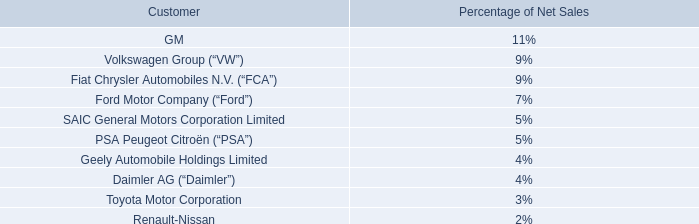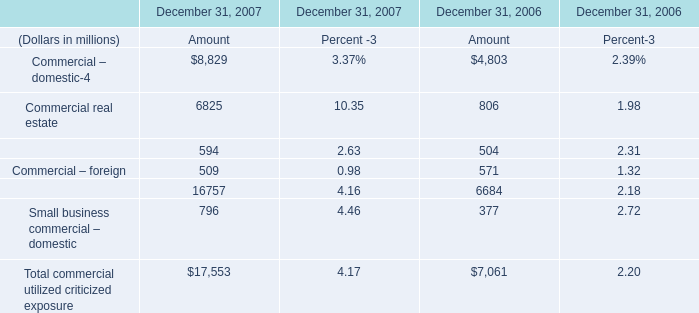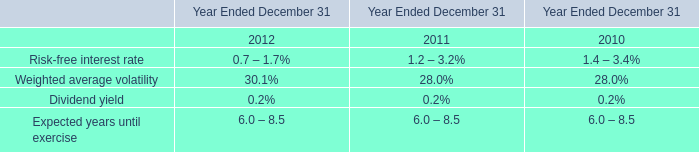Which Commercial lease financing continue to rise between 2007 and 2006? (in millions) 
Computations: (594 - 504)
Answer: 90.0. 